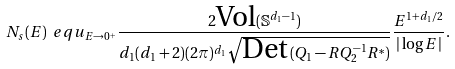<formula> <loc_0><loc_0><loc_500><loc_500>N _ { s } ( E ) \ e q u _ { E \to 0 ^ { + } } \frac { 2 \text {Vol} ( \mathbb { S } ^ { d _ { 1 } - 1 } ) } { d _ { 1 } ( d _ { 1 } + 2 ) ( 2 \pi ) ^ { d _ { 1 } } \sqrt { \text {Det} \, ( Q _ { 1 } - R Q _ { 2 } ^ { - 1 } R ^ { * } ) } } \frac { E ^ { 1 + d _ { 1 } / 2 } } { | \log E | } .</formula> 